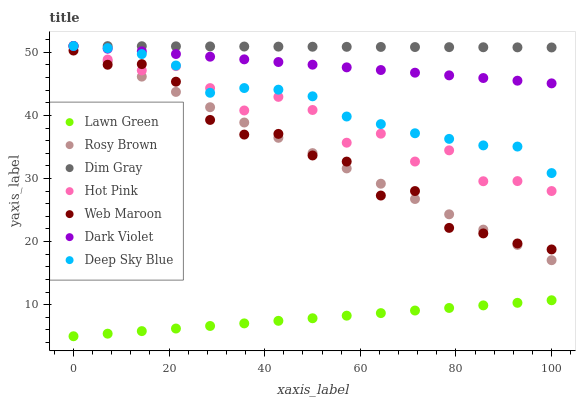Does Lawn Green have the minimum area under the curve?
Answer yes or no. Yes. Does Dim Gray have the maximum area under the curve?
Answer yes or no. Yes. Does Rosy Brown have the minimum area under the curve?
Answer yes or no. No. Does Rosy Brown have the maximum area under the curve?
Answer yes or no. No. Is Lawn Green the smoothest?
Answer yes or no. Yes. Is Hot Pink the roughest?
Answer yes or no. Yes. Is Dim Gray the smoothest?
Answer yes or no. No. Is Dim Gray the roughest?
Answer yes or no. No. Does Lawn Green have the lowest value?
Answer yes or no. Yes. Does Rosy Brown have the lowest value?
Answer yes or no. No. Does Hot Pink have the highest value?
Answer yes or no. Yes. Does Web Maroon have the highest value?
Answer yes or no. No. Is Web Maroon less than Deep Sky Blue?
Answer yes or no. Yes. Is Rosy Brown greater than Lawn Green?
Answer yes or no. Yes. Does Web Maroon intersect Rosy Brown?
Answer yes or no. Yes. Is Web Maroon less than Rosy Brown?
Answer yes or no. No. Is Web Maroon greater than Rosy Brown?
Answer yes or no. No. Does Web Maroon intersect Deep Sky Blue?
Answer yes or no. No. 